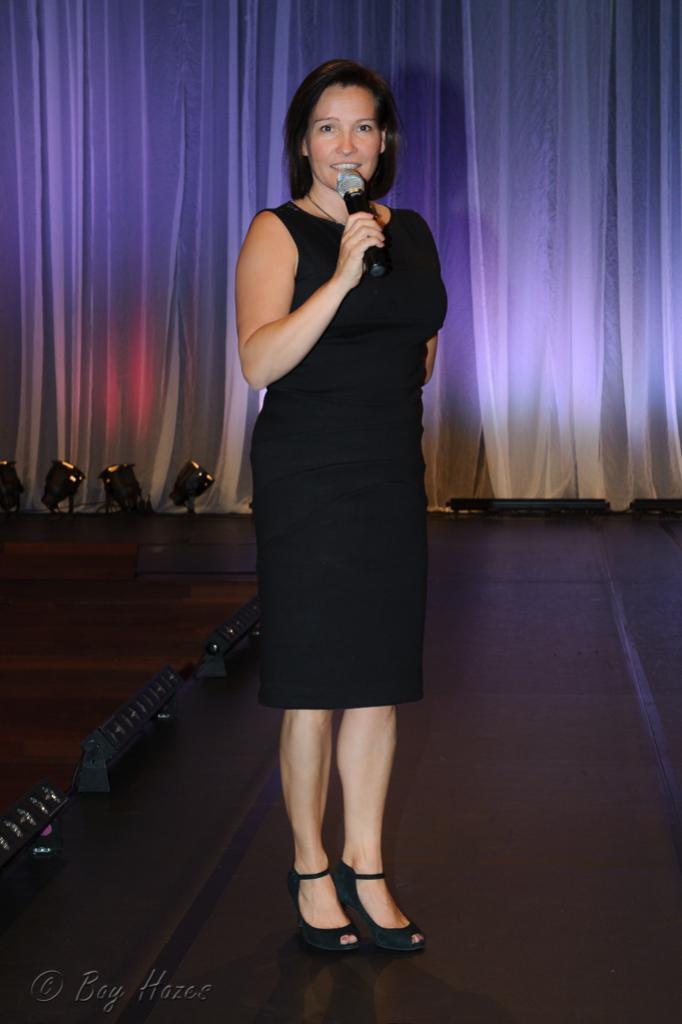How would you summarize this image in a sentence or two? In this picture there is a woman with black dress is standing and holding the microphone. At the back there is a curtain and there are lights. At the bottom there is a floor and there are objects. At the bottom left there is text. 